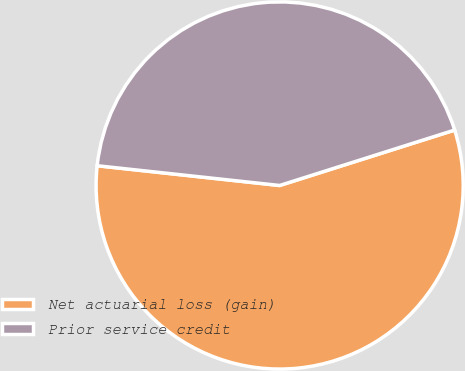Convert chart to OTSL. <chart><loc_0><loc_0><loc_500><loc_500><pie_chart><fcel>Net actuarial loss (gain)<fcel>Prior service credit<nl><fcel>56.6%<fcel>43.4%<nl></chart> 